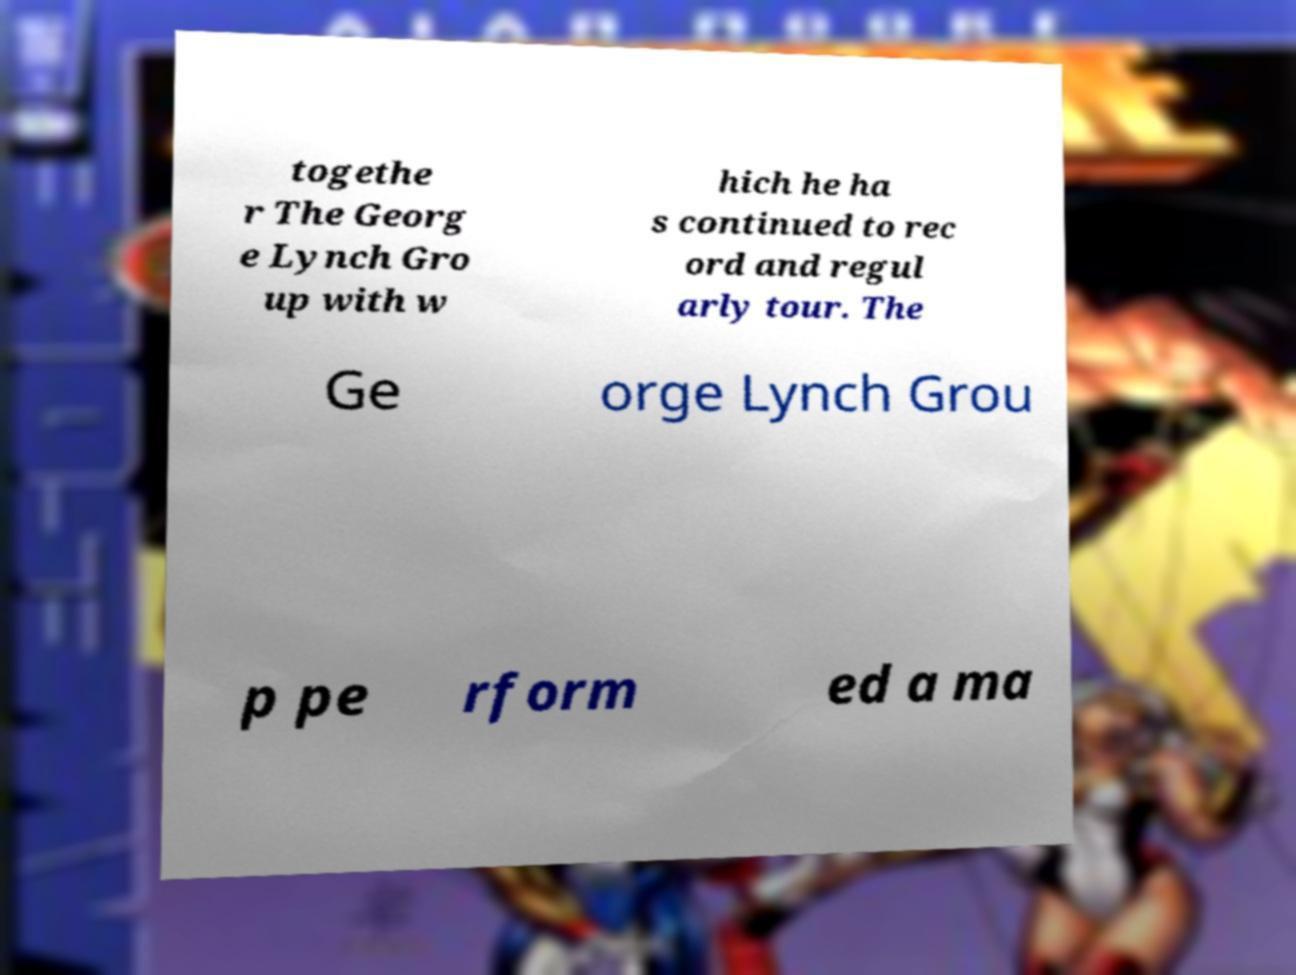Could you assist in decoding the text presented in this image and type it out clearly? togethe r The Georg e Lynch Gro up with w hich he ha s continued to rec ord and regul arly tour. The Ge orge Lynch Grou p pe rform ed a ma 